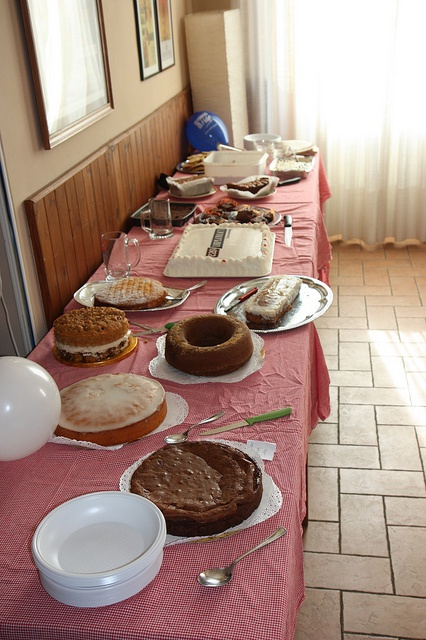Describe the objects in this image and their specific colors. I can see dining table in gray, brown, darkgray, maroon, and black tones, bowl in gray, darkgray, and lightgray tones, cake in gray, maroon, and black tones, cake in gray, tan, and maroon tones, and cake in gray and tan tones in this image. 